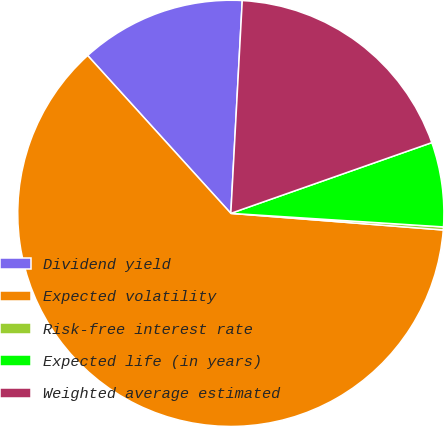Convert chart to OTSL. <chart><loc_0><loc_0><loc_500><loc_500><pie_chart><fcel>Dividend yield<fcel>Expected volatility<fcel>Risk-free interest rate<fcel>Expected life (in years)<fcel>Weighted average estimated<nl><fcel>12.58%<fcel>62.03%<fcel>0.23%<fcel>6.4%<fcel>18.76%<nl></chart> 